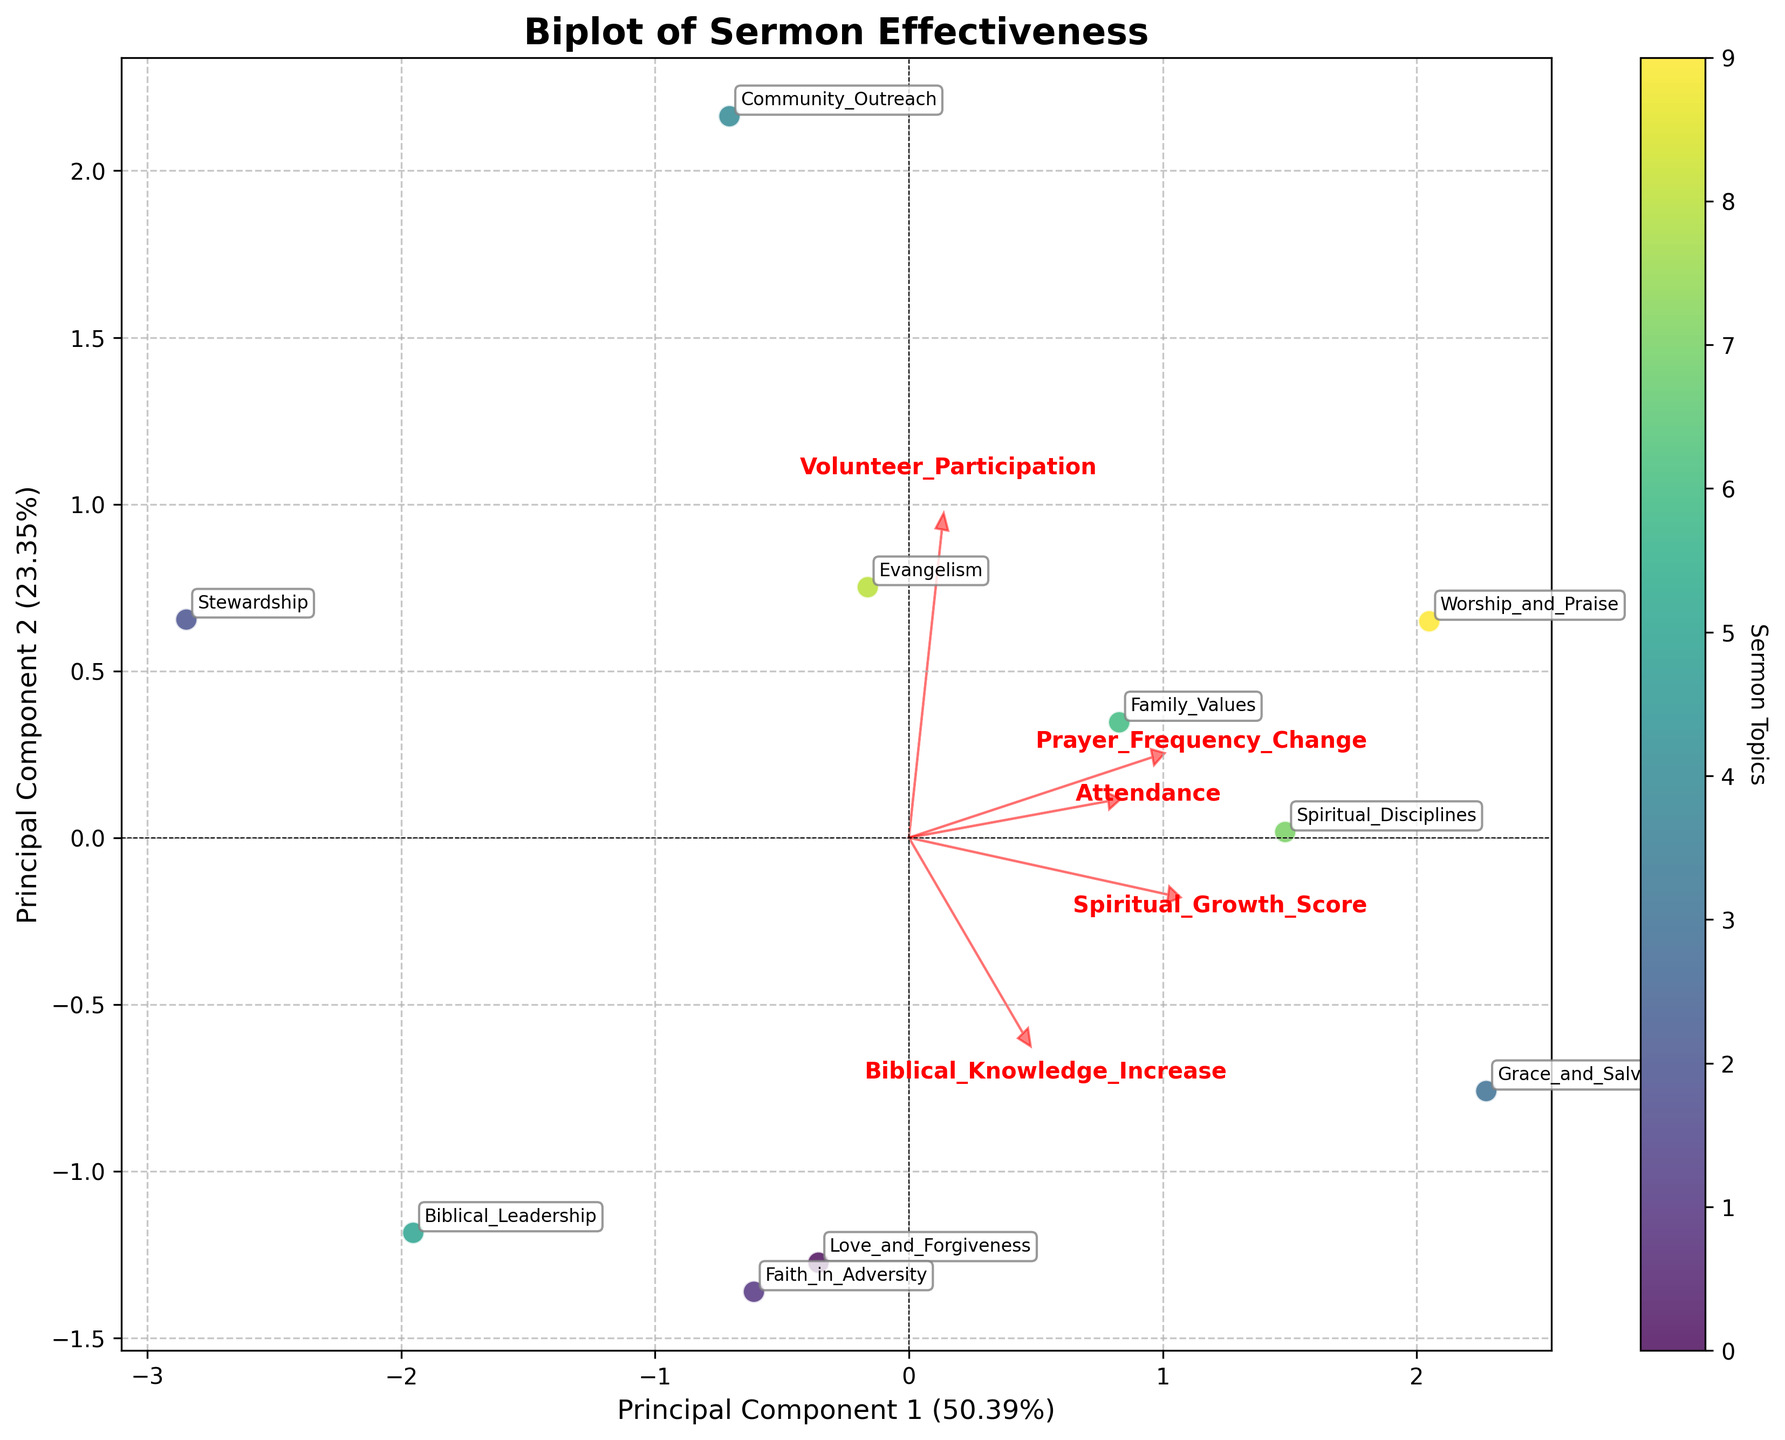What is the title of the biplot? The title of the biplot is located at the top of the figure. It provides a concise description of the focus of the plot.
Answer: Biplot of Sermon Effectiveness How many sermon topics are visualized in the plot? The number of sermon topics can be determined by counting the number of labeled points in the biplot.
Answer: 10 Which two principal components are used as the axes in the biplot? The labels on the x-axis and y-axis indicate the two principal components. These axes represent the principal components derived from the PCA.
Answer: Principal Component 1 and Principal Component 2 What color is used for the points representing the sermon topics? The color used for the points representing each sermon topic can be seen visually in the plot.
Answer: Various shades of green (viridis colormap) Which sermon topic has the highest Attendance? By identifying the point labeled with the sermon topic and checking its corresponding x or y coordinate, we can determine which topic has the highest Attendance.
Answer: Grace and Salvation What is the arrow labeled 'Spiritual_Growth_Score' indicating? The arrow labeled 'Spiritual_Growth_Score' points in the direction in which this variable increases. The length of the arrow indicates the strength of influence.
Answer: It indicates the direction and strength of Spiritual Growth Score How do the loadings for 'Volunteer_Participation' compare with 'Prayer_Frequency_Change'? By comparing the length and direction of the arrows labeled 'Volunteer_Participation' and 'Prayer_Frequency_Change', we can understand their influence on the principal components.
Answer: 'Volunteer_Participation' has a greater influence than 'Prayer_Frequency_Change.' Which sermon topic is closest to the center of the biplot? The center of the biplot is at the origin (0,0). We check which sermon topic is nearest to this point.
Answer: Biblical Leadership Which variable has the most influence on Principal Component 1? The variable with the longest arrow pointing toward the direction of Principal Component 1 has the most influence on it.
Answer: Attendance How many variables have vectors pointing in a similar direction? By visually examining the plot, we can see how many vectors (arrows) are parallel or nearly parallel, indicating similar directions.
Answer: Two (Spiritual_Growth_Score and Biblical_Knowledge_Increase) 